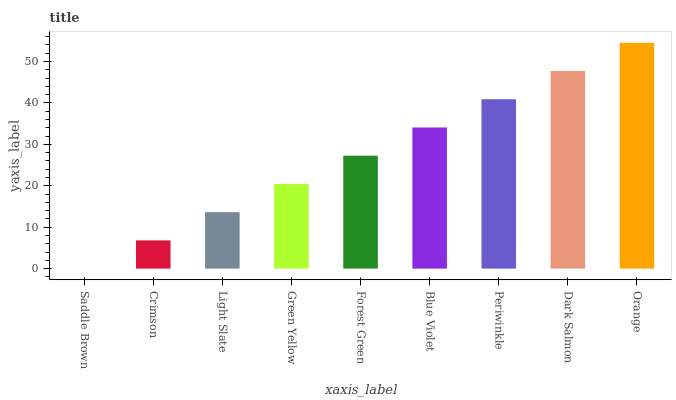Is Saddle Brown the minimum?
Answer yes or no. Yes. Is Orange the maximum?
Answer yes or no. Yes. Is Crimson the minimum?
Answer yes or no. No. Is Crimson the maximum?
Answer yes or no. No. Is Crimson greater than Saddle Brown?
Answer yes or no. Yes. Is Saddle Brown less than Crimson?
Answer yes or no. Yes. Is Saddle Brown greater than Crimson?
Answer yes or no. No. Is Crimson less than Saddle Brown?
Answer yes or no. No. Is Forest Green the high median?
Answer yes or no. Yes. Is Forest Green the low median?
Answer yes or no. Yes. Is Crimson the high median?
Answer yes or no. No. Is Orange the low median?
Answer yes or no. No. 